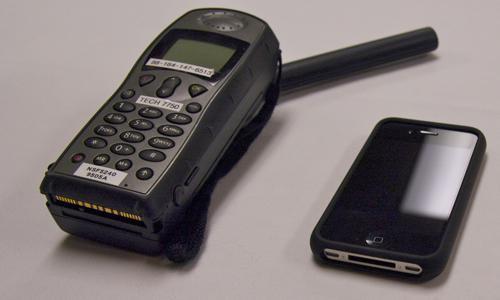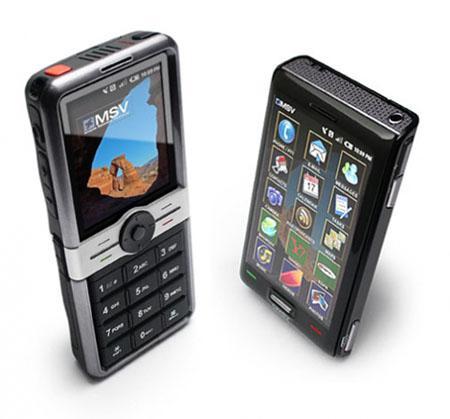The first image is the image on the left, the second image is the image on the right. Analyze the images presented: Is the assertion "One image contains a single black device, which is upright and has a rod-shape extending diagonally from its top." valid? Answer yes or no. No. The first image is the image on the left, the second image is the image on the right. For the images displayed, is the sentence "There are at least three phones." factually correct? Answer yes or no. Yes. 